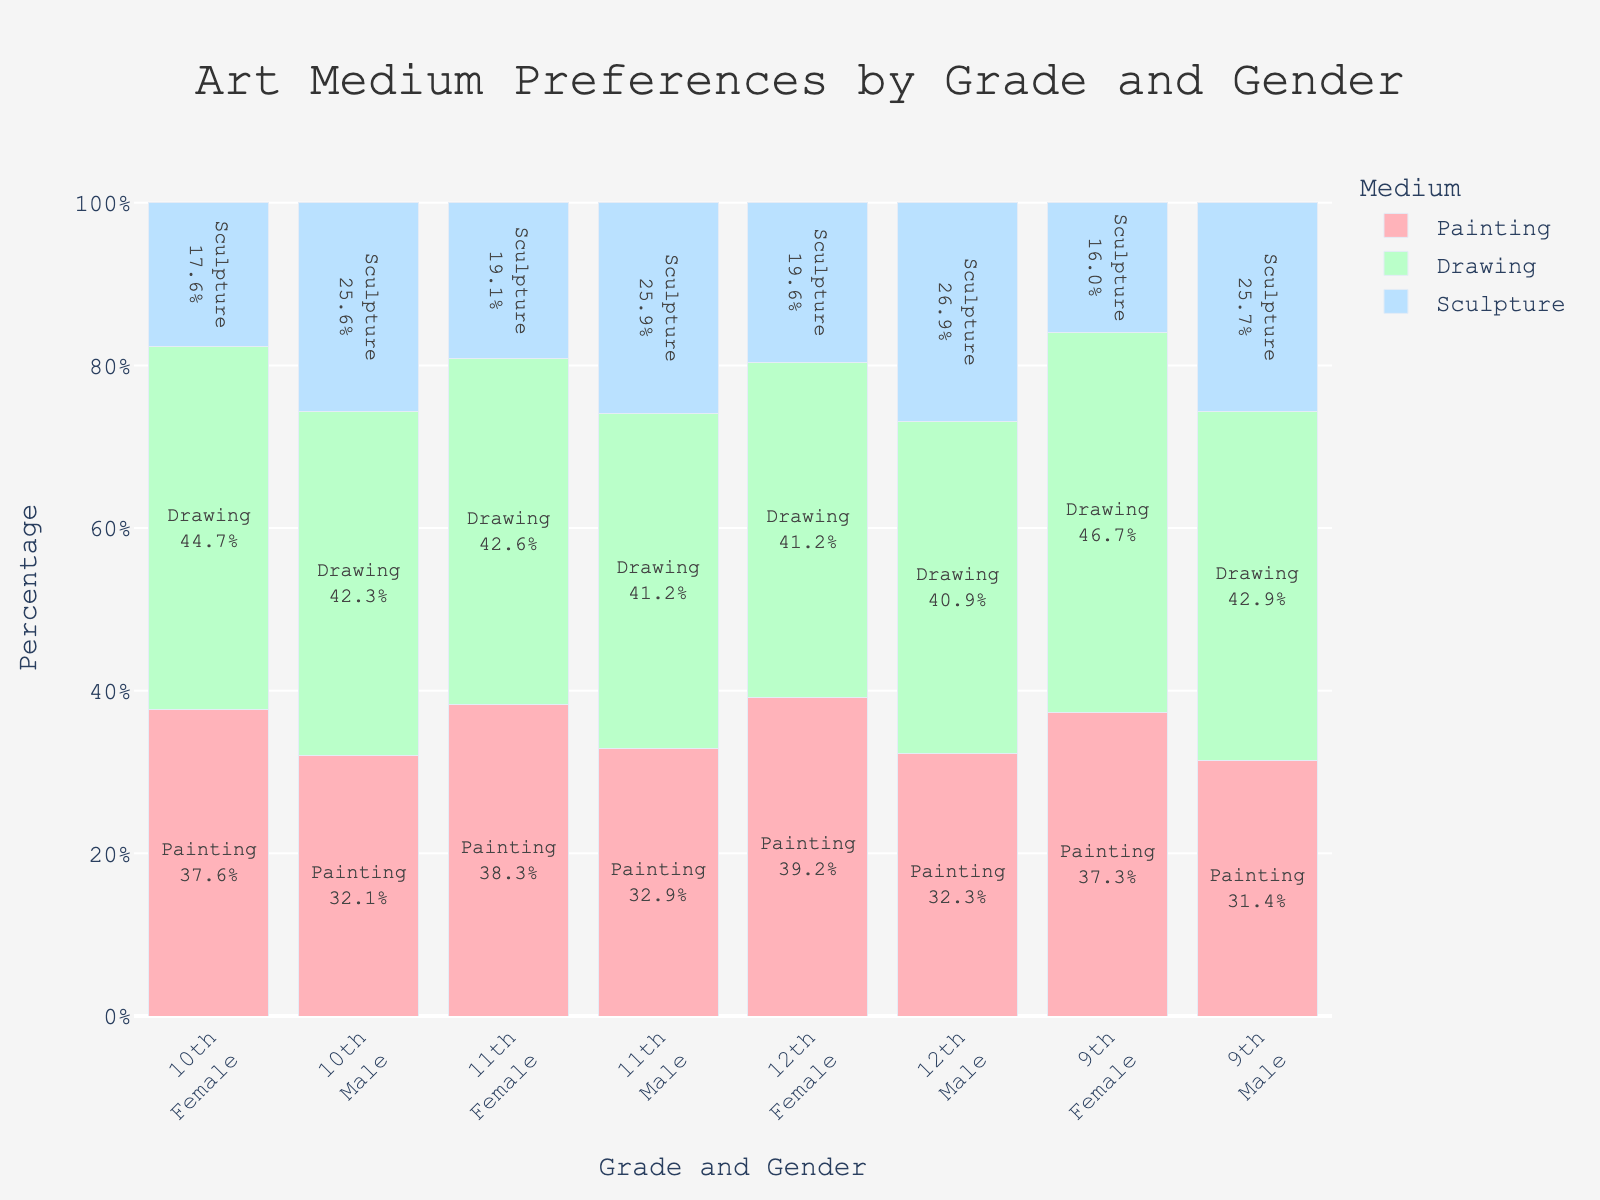What is the title of the plot? The title is located at the top center of the plot. It is a single line of text in a larger font size.
Answer: Art Medium Preferences by Grade and Gender Which medium is the most popular among 9th grade females? Look at the 9th grade female bar and identify which color segment (medium) is the largest.
Answer: Drawing Among 11th grade males, which art medium has the lowest preference? Find the segment for 11th grade males and look for the smallest segment by height.
Answer: Sculpture How do the preferences for painting compare between 10th grade males and 12th grade females? Compare the heights of the painting segments for 10th grade males and 12th grade females. The taller segment indicates a higher preference.
Answer: 12th grade females have a higher preference for painting compared to 10th grade males What is the percentage of students who prefer drawing in the 12th grade? Summarize the proportions of the drawing segment for both males and females in the 12th grade, add them up.
Answer: 40% for females + 38% for males = 78% Which medium do 9th grade males and 12th grade males have the same preference for? Compare the segments for 9th grade males and 12th grade males and find a medium where the segment height is almost the same.
Answer: Drawing What is the overall trend in preference for sculpture as the grade level increases for females? Observe the segments for sculpture across all female grades and note if they increase, decrease, or stay the same.
Answer: The preference for sculpture among females increases as the grade level increases Which gender shows a more consistent preference for drawing across all grades? Evaluate the consistency of the drawing segments across all grades for both genders. The closer the segment sizes, the more consistent the preference.
Answer: Females What percentage of 11th grade students prefer painting? Summarize the proportions of the painting segment for both males and females in the 11th grade, adding them together.
Answer: (36/94) + (28/85) ≈ 0.38 + 0.33 ≈ 71% Which grade has the highest variability in art medium preferences among females? Look at the segments for all grades among females and determine which grade has segments of the most varied sizes.
Answer: 12th grade 